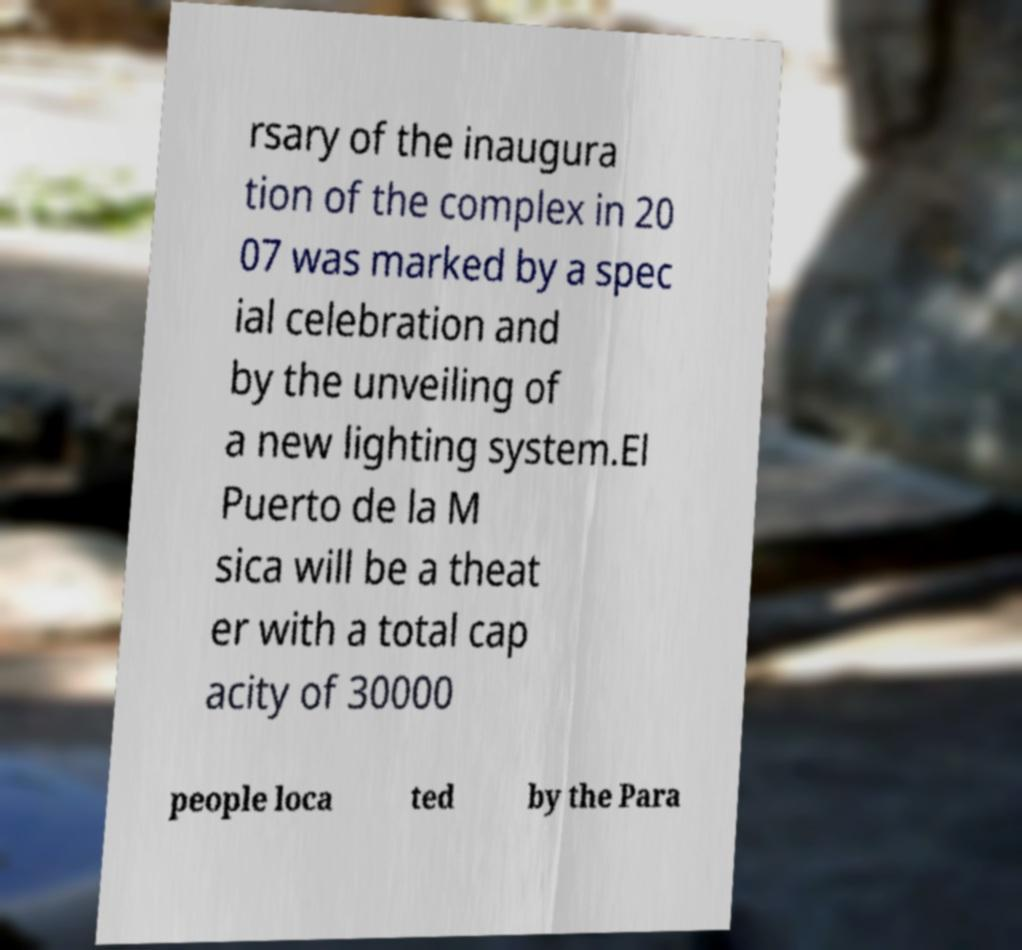I need the written content from this picture converted into text. Can you do that? rsary of the inaugura tion of the complex in 20 07 was marked by a spec ial celebration and by the unveiling of a new lighting system.El Puerto de la M sica will be a theat er with a total cap acity of 30000 people loca ted by the Para 